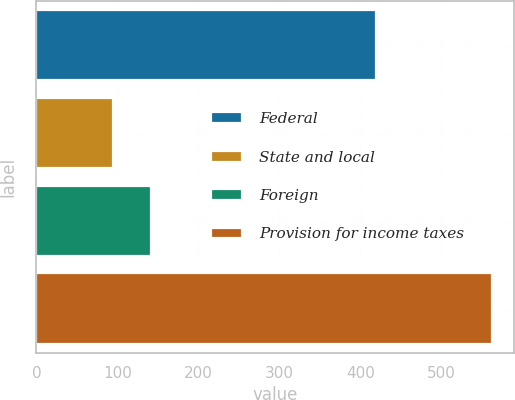<chart> <loc_0><loc_0><loc_500><loc_500><bar_chart><fcel>Federal<fcel>State and local<fcel>Foreign<fcel>Provision for income taxes<nl><fcel>419<fcel>95<fcel>141.7<fcel>562<nl></chart> 